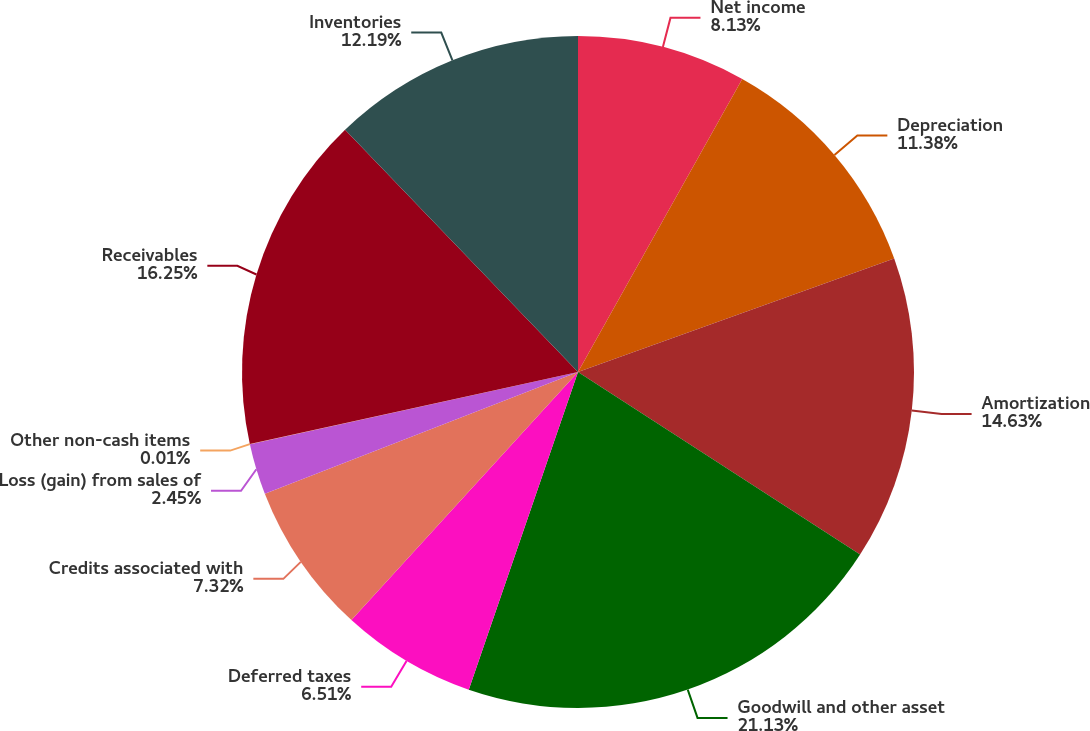<chart> <loc_0><loc_0><loc_500><loc_500><pie_chart><fcel>Net income<fcel>Depreciation<fcel>Amortization<fcel>Goodwill and other asset<fcel>Deferred taxes<fcel>Credits associated with<fcel>Loss (gain) from sales of<fcel>Other non-cash items<fcel>Receivables<fcel>Inventories<nl><fcel>8.13%<fcel>11.38%<fcel>14.63%<fcel>21.13%<fcel>6.51%<fcel>7.32%<fcel>2.45%<fcel>0.01%<fcel>16.25%<fcel>12.19%<nl></chart> 